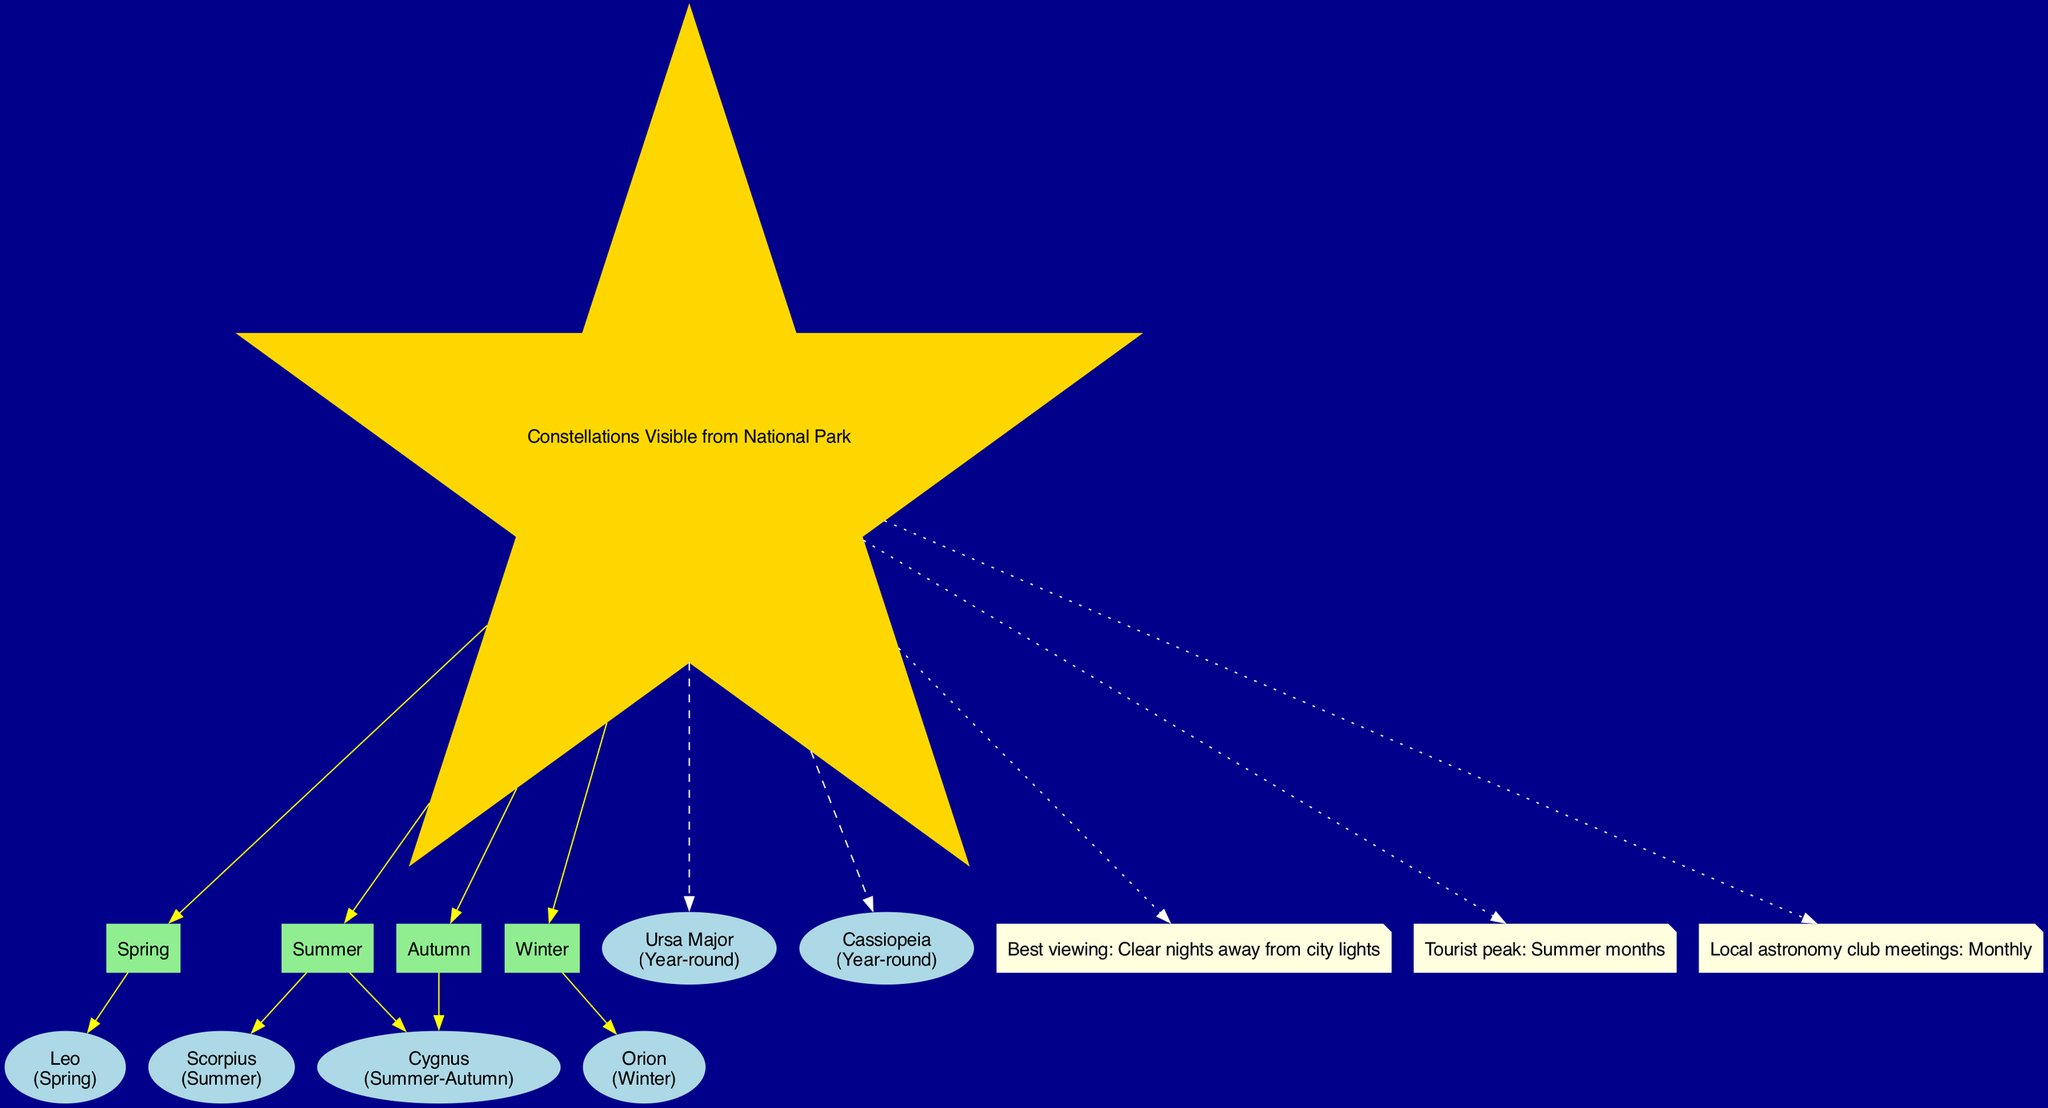What constellations are visible in Winter? The diagram indicates that the constellation Orion is visible during the Winter season, as specified in its visibility label.
Answer: Orion How many constellations are visible year-round? The diagram labels two constellations, Ursa Major and Cassiopeia, as being visible year-round. Thus, by counting these specific nodes, the answer is two.
Answer: 2 Which season includes the constellation Scorpius? The diagram notes that Scorpius is specifically visible during the Summer season, connecting it with the Summer node.
Answer: Summer What is the best condition for viewing constellations from the national park? The diagram includes a note stating “Best viewing: Clear nights away from city lights,” directly identifying the conditions for optimal viewing.
Answer: Clear nights away from city lights Which constellation is associated with Spring? According to the diagram, the constellation Leo is linked to the Spring season as it is represented under this seasonal node.
Answer: Leo How many seasonal nodes are present in the diagram? The diagram includes four seasonal nodes: Spring, Summer, Autumn, and Winter. By simply counting these nodes, the answer is four.
Answer: 4 What does the note say about tourist activity? The diagram contains a note indicating "Tourist peak: Summer months," which highlights when tourist activity is at its highest.
Answer: Summer months In which seasons can Cygnus be seen? The diagram illustrates that Cygnus is visible during both Summer and Autumn, as it connects to the respective seasonal nodes.
Answer: Summer-Autumn What color are the nodes representing constellations? The diagram shows that all constellation nodes are drawn in an oval shape with no specific color mentioned for this type; however, they are visually differentiated.
Answer: Oval 